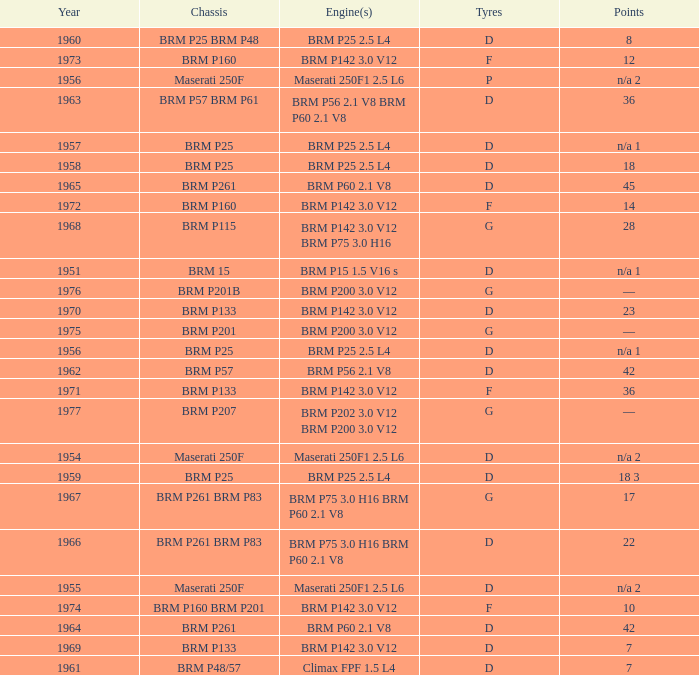Name the chassis of 1961 BRM P48/57. 